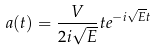Convert formula to latex. <formula><loc_0><loc_0><loc_500><loc_500>a ( t ) = \frac { V } { 2 i \sqrt { E } } t e ^ { - i \sqrt { E } t }</formula> 